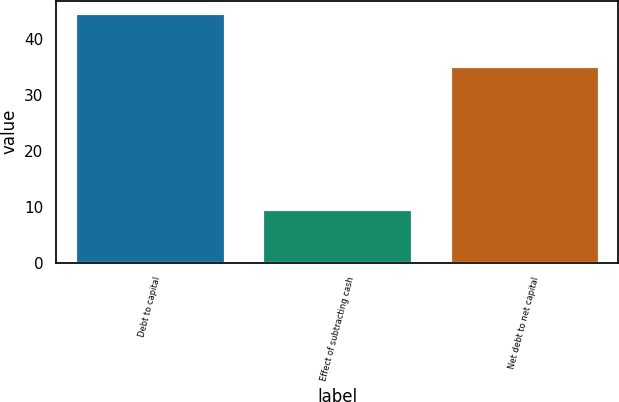Convert chart to OTSL. <chart><loc_0><loc_0><loc_500><loc_500><bar_chart><fcel>Debt to capital<fcel>Effect of subtracting cash<fcel>Net debt to net capital<nl><fcel>44.6<fcel>9.5<fcel>35.1<nl></chart> 